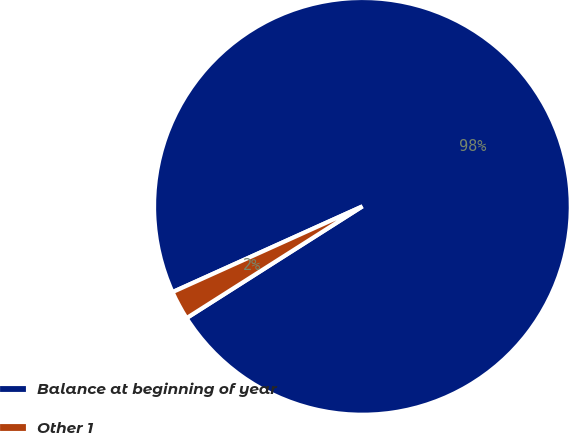<chart> <loc_0><loc_0><loc_500><loc_500><pie_chart><fcel>Balance at beginning of year<fcel>Other 1<nl><fcel>97.74%<fcel>2.26%<nl></chart> 